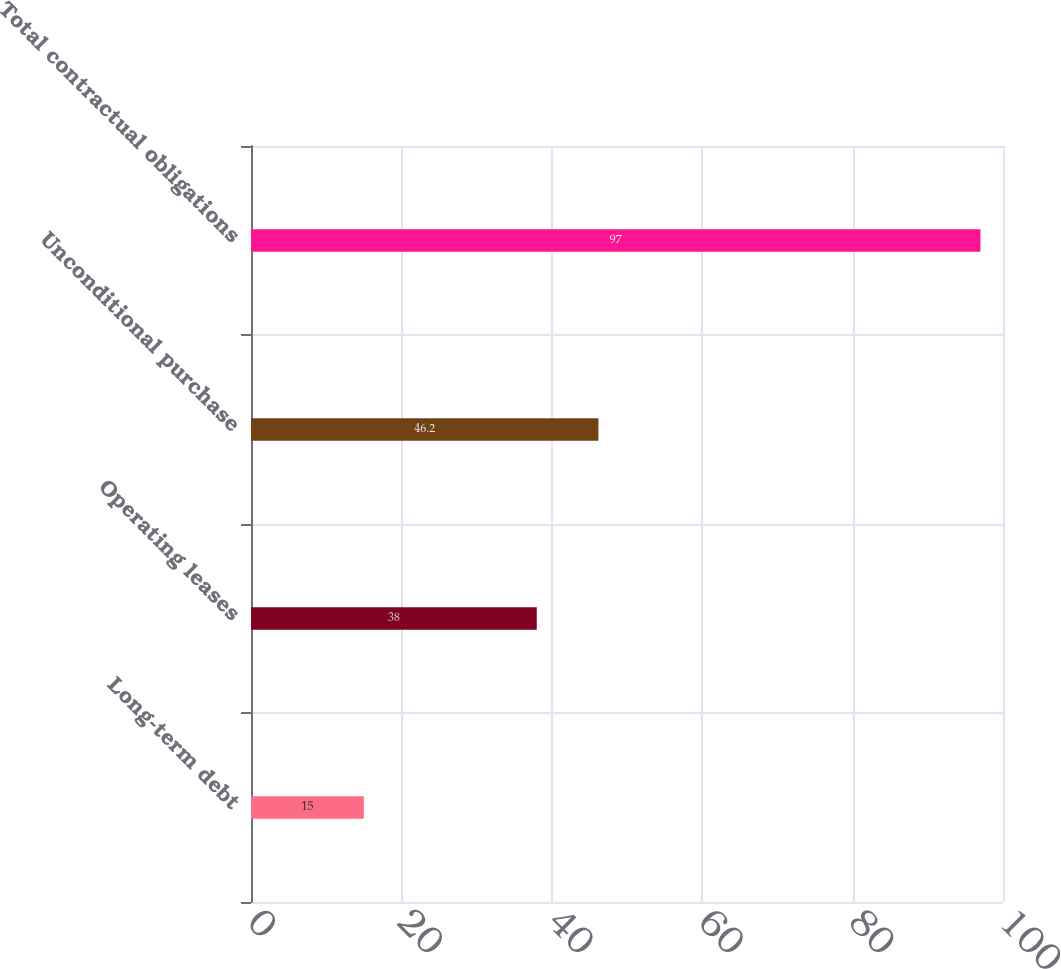Convert chart to OTSL. <chart><loc_0><loc_0><loc_500><loc_500><bar_chart><fcel>Long-term debt<fcel>Operating leases<fcel>Unconditional purchase<fcel>Total contractual obligations<nl><fcel>15<fcel>38<fcel>46.2<fcel>97<nl></chart> 